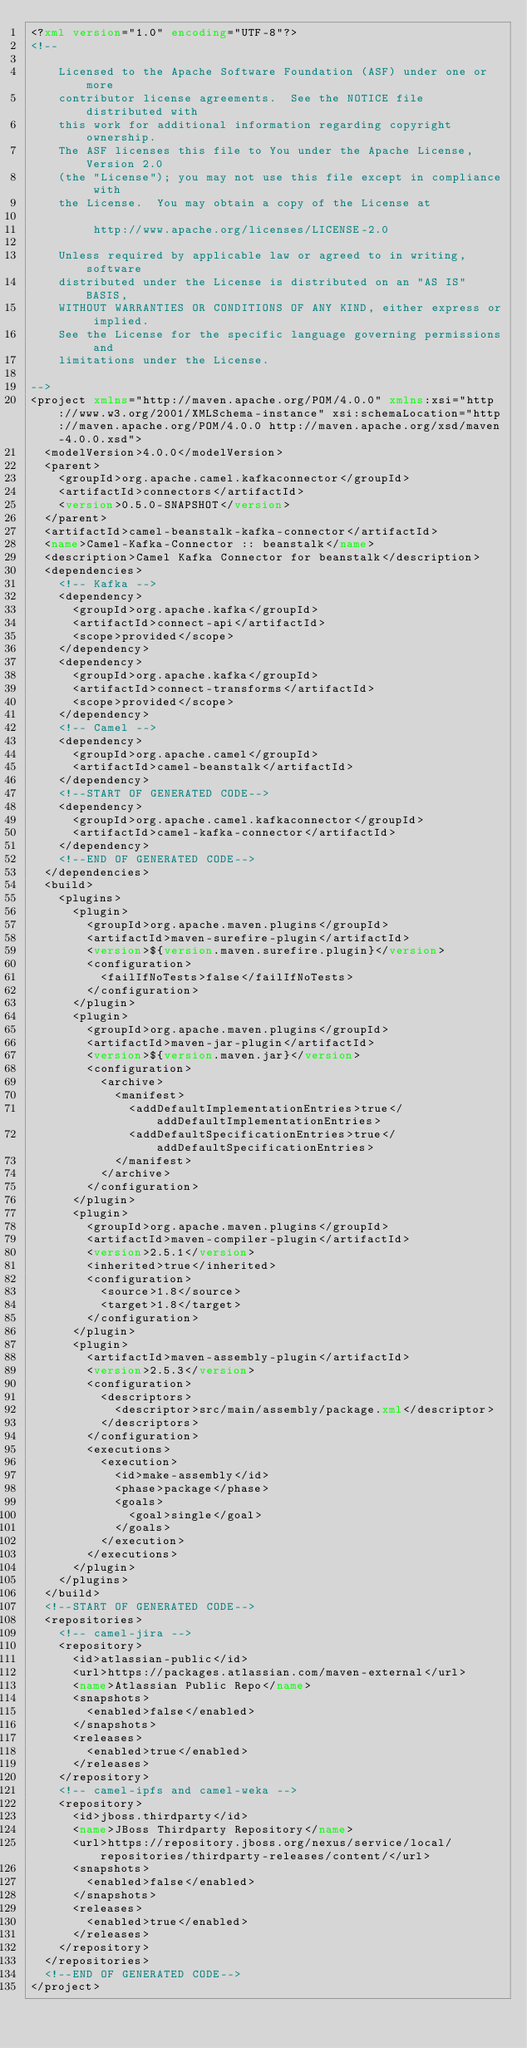Convert code to text. <code><loc_0><loc_0><loc_500><loc_500><_XML_><?xml version="1.0" encoding="UTF-8"?>
<!--

    Licensed to the Apache Software Foundation (ASF) under one or more
    contributor license agreements.  See the NOTICE file distributed with
    this work for additional information regarding copyright ownership.
    The ASF licenses this file to You under the Apache License, Version 2.0
    (the "License"); you may not use this file except in compliance with
    the License.  You may obtain a copy of the License at

         http://www.apache.org/licenses/LICENSE-2.0

    Unless required by applicable law or agreed to in writing, software
    distributed under the License is distributed on an "AS IS" BASIS,
    WITHOUT WARRANTIES OR CONDITIONS OF ANY KIND, either express or implied.
    See the License for the specific language governing permissions and
    limitations under the License.

-->
<project xmlns="http://maven.apache.org/POM/4.0.0" xmlns:xsi="http://www.w3.org/2001/XMLSchema-instance" xsi:schemaLocation="http://maven.apache.org/POM/4.0.0 http://maven.apache.org/xsd/maven-4.0.0.xsd">
  <modelVersion>4.0.0</modelVersion>
  <parent>
    <groupId>org.apache.camel.kafkaconnector</groupId>
    <artifactId>connectors</artifactId>
    <version>0.5.0-SNAPSHOT</version>
  </parent>
  <artifactId>camel-beanstalk-kafka-connector</artifactId>
  <name>Camel-Kafka-Connector :: beanstalk</name>
  <description>Camel Kafka Connector for beanstalk</description>
  <dependencies>
    <!-- Kafka -->
    <dependency>
      <groupId>org.apache.kafka</groupId>
      <artifactId>connect-api</artifactId>
      <scope>provided</scope>
    </dependency>
    <dependency>
      <groupId>org.apache.kafka</groupId>
      <artifactId>connect-transforms</artifactId>
      <scope>provided</scope>
    </dependency>
    <!-- Camel -->
    <dependency>
      <groupId>org.apache.camel</groupId>
      <artifactId>camel-beanstalk</artifactId>
    </dependency>
    <!--START OF GENERATED CODE-->
    <dependency>
      <groupId>org.apache.camel.kafkaconnector</groupId>
      <artifactId>camel-kafka-connector</artifactId>
    </dependency>
    <!--END OF GENERATED CODE-->
  </dependencies>
  <build>
    <plugins>
      <plugin>
        <groupId>org.apache.maven.plugins</groupId>
        <artifactId>maven-surefire-plugin</artifactId>
        <version>${version.maven.surefire.plugin}</version>
        <configuration>
          <failIfNoTests>false</failIfNoTests>
        </configuration>
      </plugin>
      <plugin>
        <groupId>org.apache.maven.plugins</groupId>
        <artifactId>maven-jar-plugin</artifactId>
        <version>${version.maven.jar}</version>
        <configuration>
          <archive>
            <manifest>
              <addDefaultImplementationEntries>true</addDefaultImplementationEntries>
              <addDefaultSpecificationEntries>true</addDefaultSpecificationEntries>
            </manifest>
          </archive>
        </configuration>
      </plugin>
      <plugin>
        <groupId>org.apache.maven.plugins</groupId>
        <artifactId>maven-compiler-plugin</artifactId>
        <version>2.5.1</version>
        <inherited>true</inherited>
        <configuration>
          <source>1.8</source>
          <target>1.8</target>
        </configuration>
      </plugin>
      <plugin>
        <artifactId>maven-assembly-plugin</artifactId>
        <version>2.5.3</version>
        <configuration>
          <descriptors>
            <descriptor>src/main/assembly/package.xml</descriptor>
          </descriptors>
        </configuration>
        <executions>
          <execution>
            <id>make-assembly</id>
            <phase>package</phase>
            <goals>
              <goal>single</goal>
            </goals>
          </execution>
        </executions>
      </plugin>
    </plugins>
  </build>
  <!--START OF GENERATED CODE-->
  <repositories>
    <!-- camel-jira -->
    <repository>
      <id>atlassian-public</id>
      <url>https://packages.atlassian.com/maven-external</url>
      <name>Atlassian Public Repo</name>
      <snapshots>
        <enabled>false</enabled>
      </snapshots>
      <releases>
        <enabled>true</enabled>
      </releases>
    </repository>
    <!-- camel-ipfs and camel-weka -->
    <repository>
      <id>jboss.thirdparty</id>
      <name>JBoss Thirdparty Repository</name>
      <url>https://repository.jboss.org/nexus/service/local/repositories/thirdparty-releases/content/</url>
      <snapshots>
        <enabled>false</enabled>
      </snapshots>
      <releases>
        <enabled>true</enabled>
      </releases>
    </repository>
  </repositories>
  <!--END OF GENERATED CODE-->
</project>
</code> 